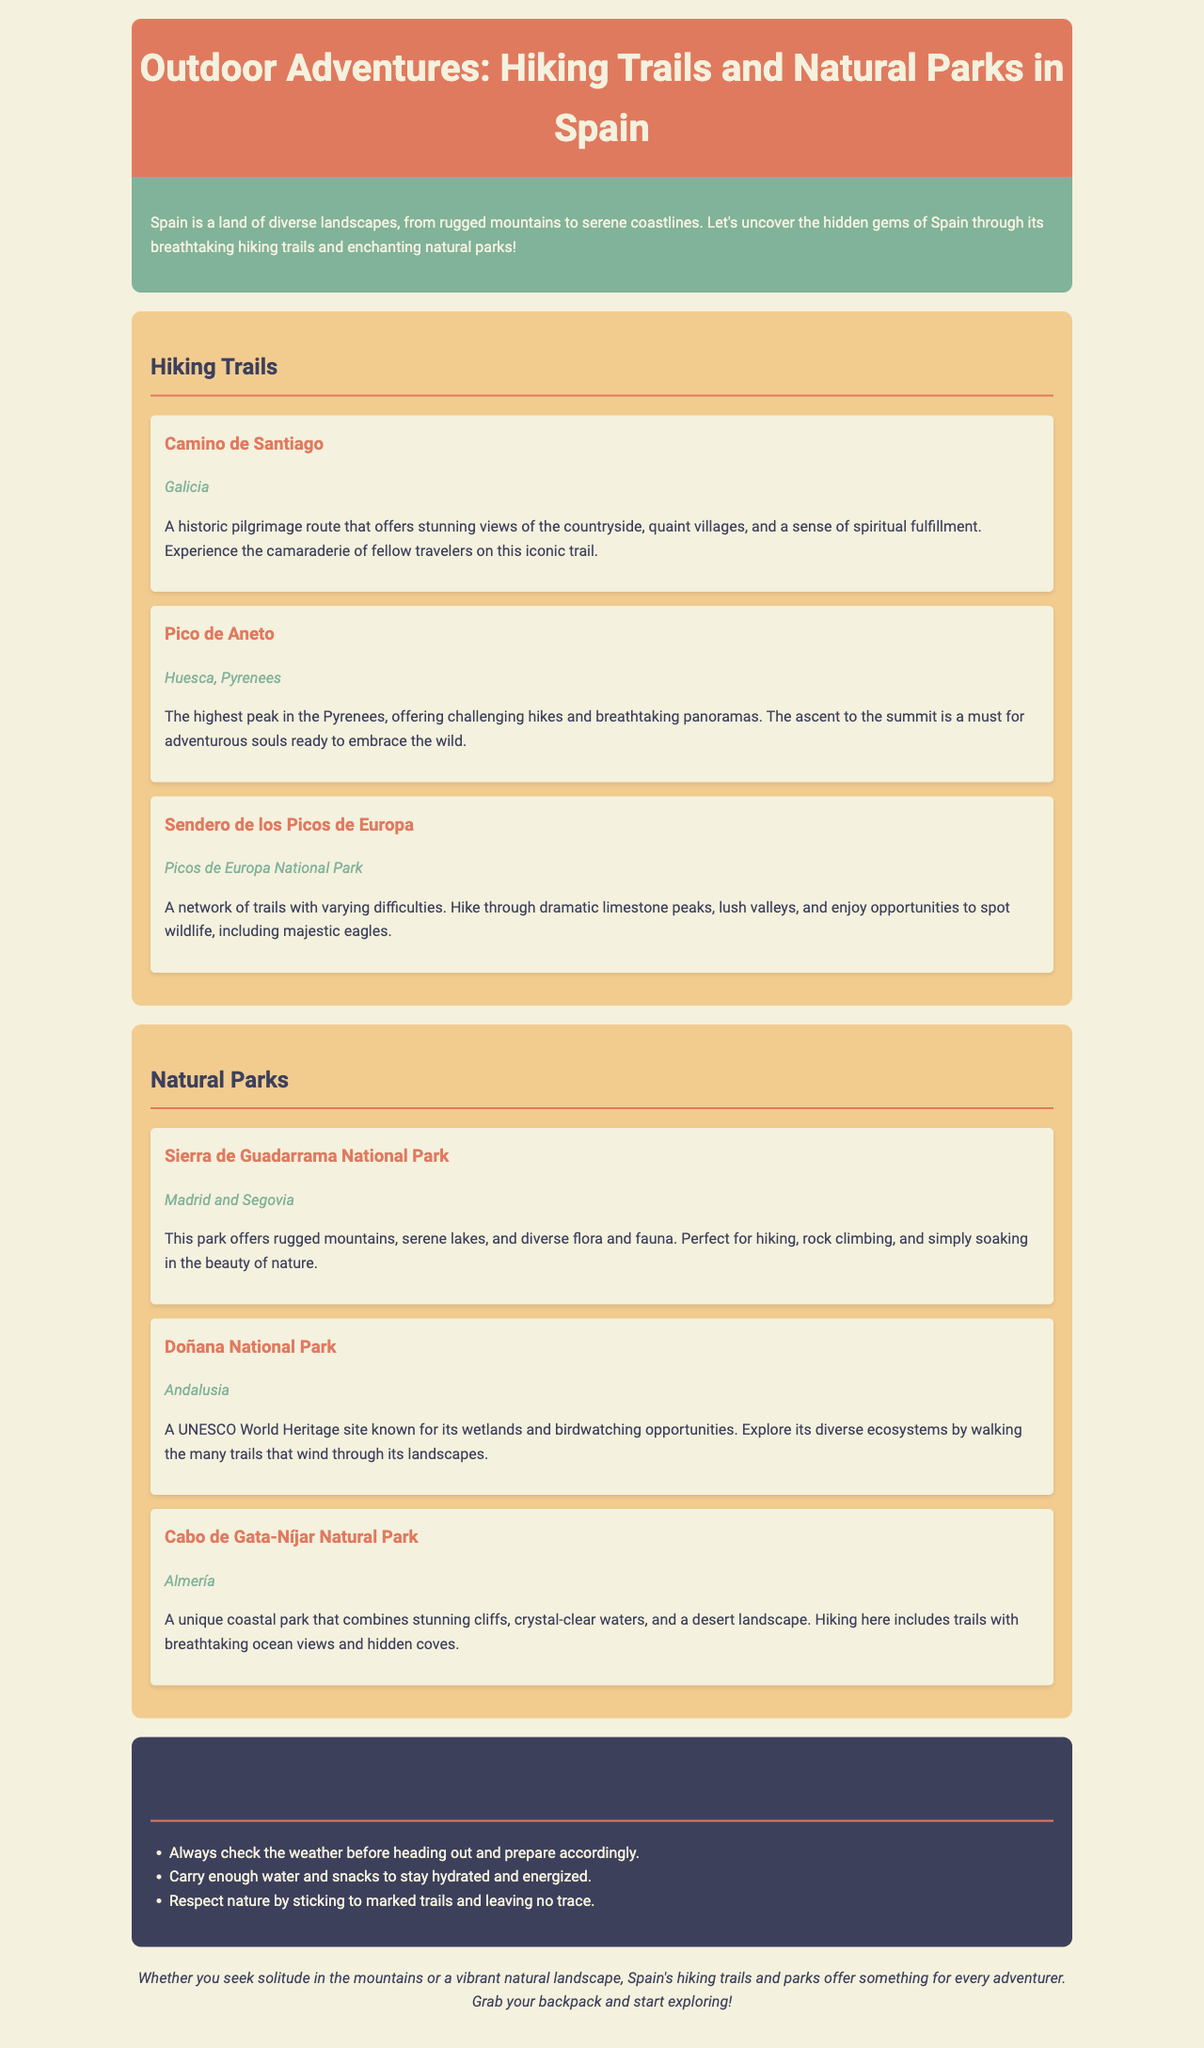What is the title of the brochure? The title of the brochure is presented in the header section as "Outdoor Adventures: Hiking Trails and Natural Parks in Spain."
Answer: Outdoor Adventures: Hiking Trails and Natural Parks in Spain How many hiking trails are mentioned in the brochure? The brochure lists a total of three hiking trails under the Hiking Trails section.
Answer: 3 What is the location of the Camino de Santiago? The location is specified in the document as "Galicia."
Answer: Galicia Which natural park is located in Andalusia? The document states that Doñana National Park is located in Andalusia.
Answer: Doñana National Park What is a key feature of Cabo de Gata-Níjar Natural Park? The brochure describes Cabo de Gata-Níjar Natural Park as featuring "stunning cliffs, crystal-clear waters, and a desert landscape."
Answer: Stunning cliffs, crystal-clear waters, and a desert landscape What type of activities can you do in Sierra de Guadarrama National Park? The document mentions activities such as hiking, rock climbing, and soaking in the beauty of nature.
Answer: Hiking, rock climbing What is a UNESCO World Heritage site mentioned in the brochure? The document identifies Doñana National Park as a UNESCO World Heritage site.
Answer: Doñana National Park What should you carry for your hiking adventures? The tips section advises carrying enough water and snacks to stay hydrated and energized.
Answer: Water and snacks What is the overall theme of the brochure? The document's theme focuses on exploring hiking trails and natural parks in Spain.
Answer: Exploring hiking trails and natural parks in Spain 